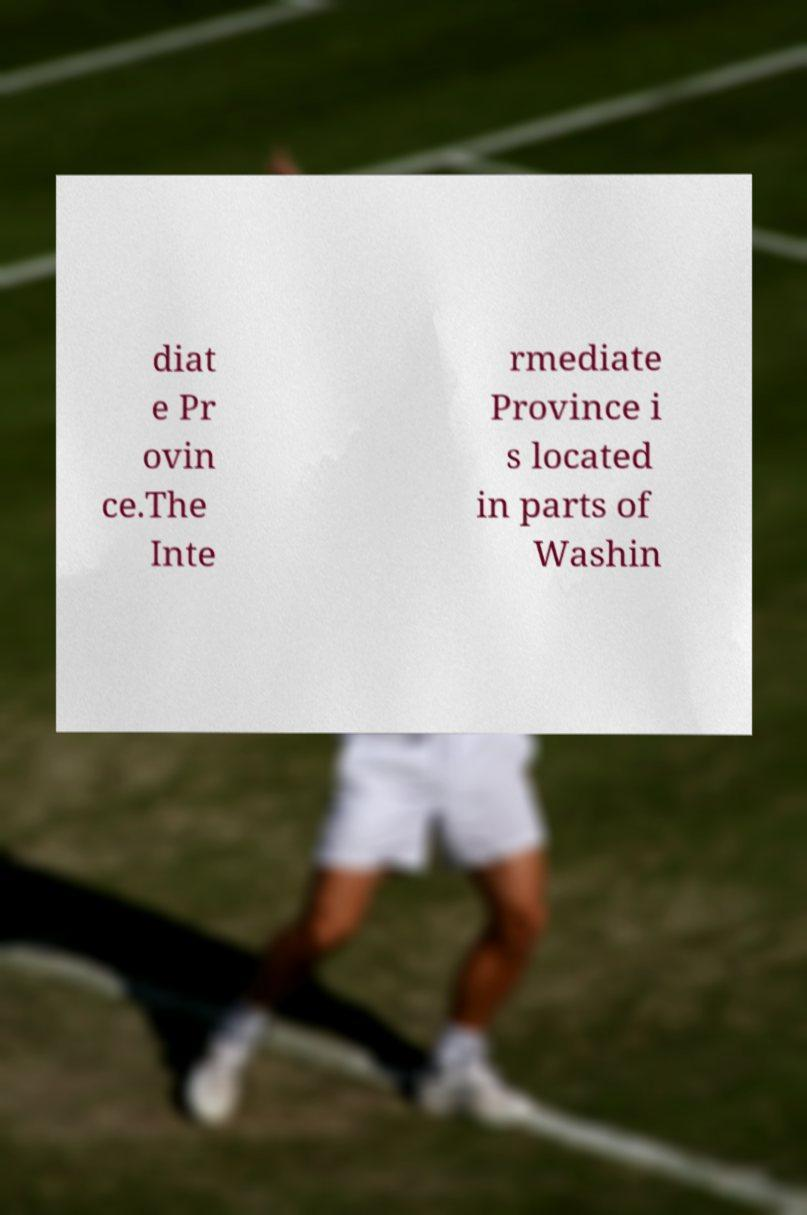Can you accurately transcribe the text from the provided image for me? diat e Pr ovin ce.The Inte rmediate Province i s located in parts of Washin 